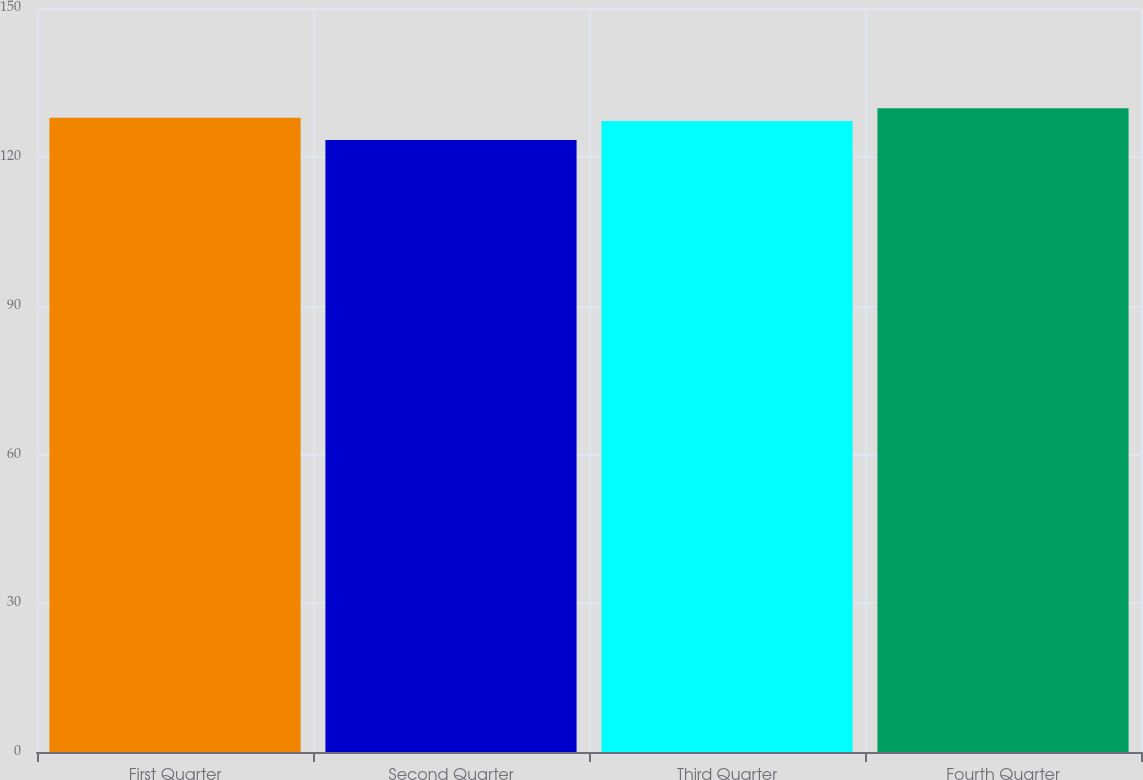<chart> <loc_0><loc_0><loc_500><loc_500><bar_chart><fcel>First Quarter<fcel>Second Quarter<fcel>Third Quarter<fcel>Fourth Quarter<nl><fcel>127.85<fcel>123.37<fcel>127.21<fcel>129.77<nl></chart> 